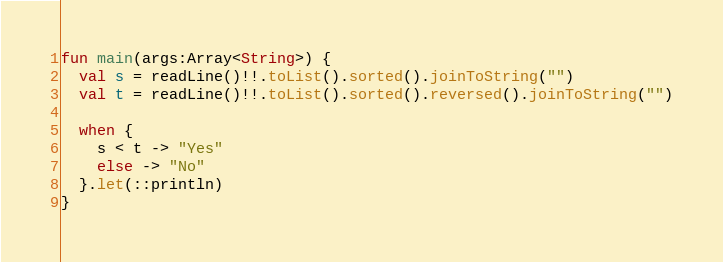<code> <loc_0><loc_0><loc_500><loc_500><_Kotlin_>fun main(args:Array<String>) {
  val s = readLine()!!.toList().sorted().joinToString("")
  val t = readLine()!!.toList().sorted().reversed().joinToString("")
  
  when {
    s < t -> "Yes"
    else -> "No"
  }.let(::println)
}</code> 